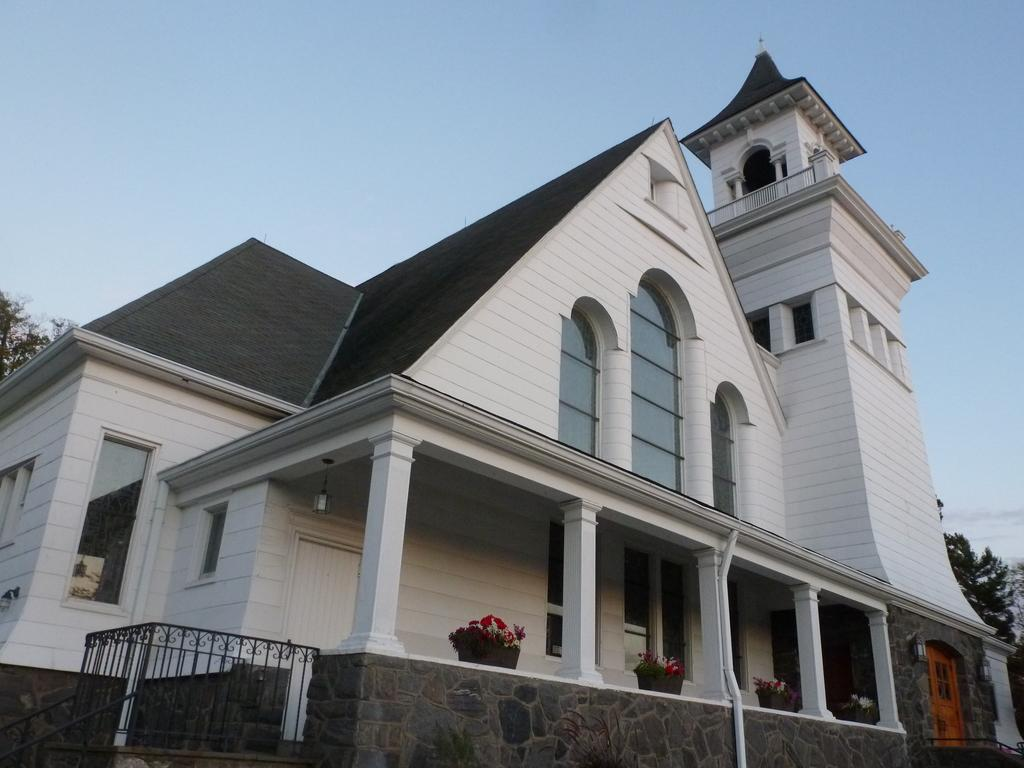What type of structure is present in the image? There is a building in the image. What features can be observed on the building? The building has windows, doors, and pillars. What objects are present near the building? There are flower pots and trees in the image. What type of barrier is visible in the image? There is a fence in the image. What can be seen in the background of the image? The sky is visible in the background of the image. Can you tell me how many elbows the horse has in the image? There is no horse present in the image, and therefore no elbows can be observed. Is anyone swimming in the image? There is no indication of swimming or a body of water in the image. 